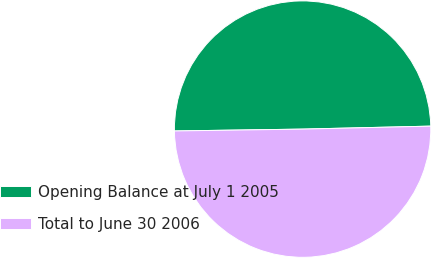<chart> <loc_0><loc_0><loc_500><loc_500><pie_chart><fcel>Opening Balance at July 1 2005<fcel>Total to June 30 2006<nl><fcel>49.86%<fcel>50.14%<nl></chart> 